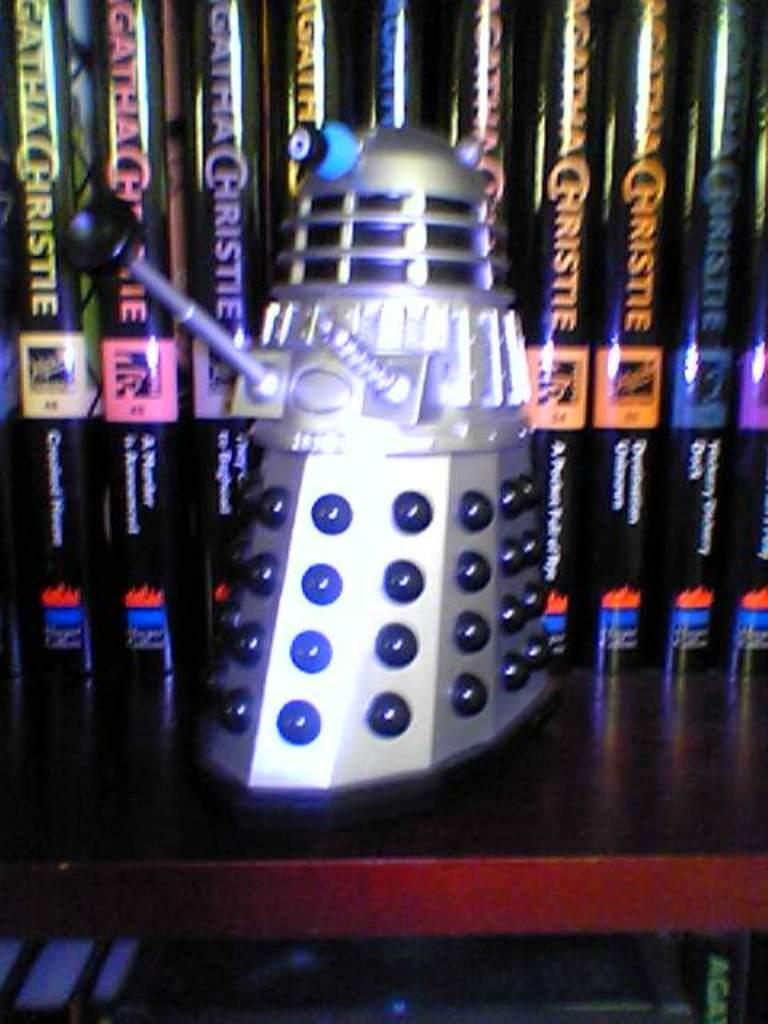<image>
Share a concise interpretation of the image provided. A book shelf with a display of books by Agatha Christie and a collectible from Dr. Who 